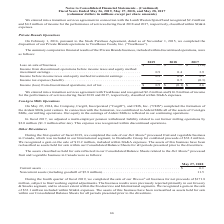According to Conagra Brands's financial document, When did the company complete the disposition of their Private Brands operations to TreeHouse Foods, Inc.?  According to the financial document, February 1, 2016. The relevant text states: "On February 1, 2016, pursuant to the Stock Purchase Agreement, dated as of November 1, 2015, we completed the..." Also, What were the incomes before income taxes and equity method investment earnings in the fiscal years 2017 and 2018, respectively? The document shows two values: 2.3 and 0.4 (in millions). From the document: "axes and equity method investment earnings. . 0.9 0.4 3.9 s and equity method investment earnings . 0.9 0.4 2.3..." Also, What was the income tax expense (benefit), in millions, in the fiscal year 2018? According to the financial document, 0.5. The relevant text states: "Income tax expense (benefit). . — 0.5 (0.3)..." Also, can you calculate: What is the ratio of income  from discontinued operations (net of tax) to income for the performance of services (classified within SG&A expenses) during fiscal 2017? Based on the calculation: 2.6/16.9 , the result is 0.15. This is based on the information: "ontinued operations, net of tax . $ 0.9 $ (0.1) $ 2.6 t with TreeHouse and recognized $2.2 million and $16.9 million of income..." The key data points involved are: 16.9, 2.6. Also, can you calculate: What is the percentage change in income from discontinued operations (net of tax) from 2017 to 2019? To answer this question, I need to perform calculations using the financial data. The calculation is: (0.9-2.6)/2.6 , which equals -65.38 (percentage). This is based on the information: "me taxes and equity method investment earnings. . 0.9 0.4 3.9 ontinued operations, net of tax . $ 0.9 $ (0.1) $ 2.6..." The key data points involved are: 0.9, 2.6. Also, can you calculate: What is the proportion of income tax benefit over income from discontinued operations during the fiscal year 2017? Based on the calculation: 0.3/2.6 , the result is 0.12. This is based on the information: "ontinued operations, net of tax . $ 0.9 $ (0.1) $ 2.6 Income tax expense (benefit). . — 0.5 (0.3)..." The key data points involved are: 0.3, 2.6. 